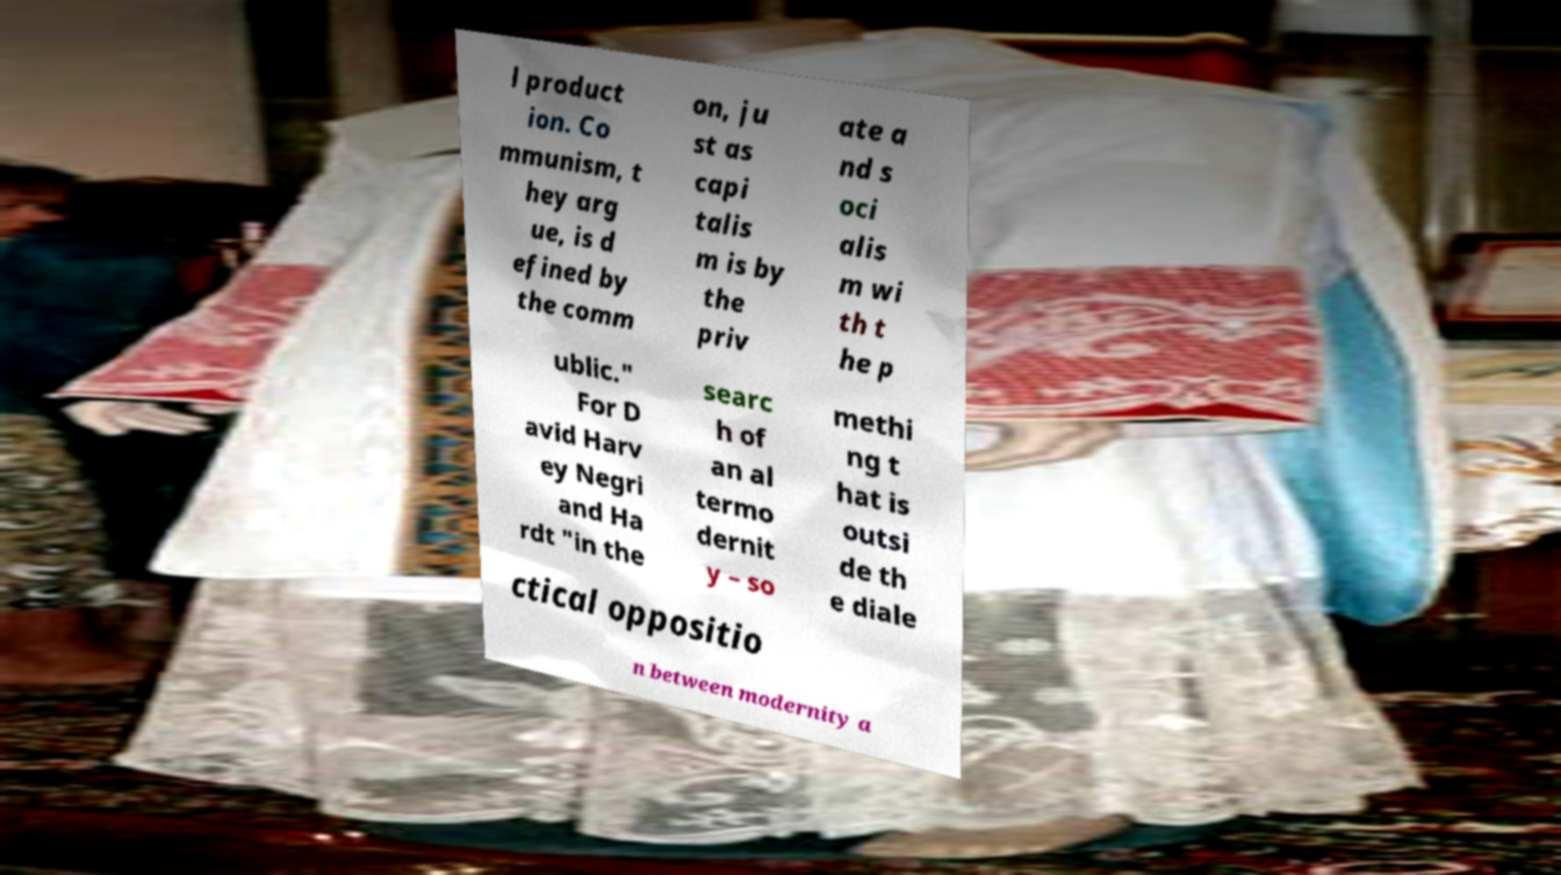There's text embedded in this image that I need extracted. Can you transcribe it verbatim? l product ion. Co mmunism, t hey arg ue, is d efined by the comm on, ju st as capi talis m is by the priv ate a nd s oci alis m wi th t he p ublic." For D avid Harv ey Negri and Ha rdt "in the searc h of an al termo dernit y – so methi ng t hat is outsi de th e diale ctical oppositio n between modernity a 